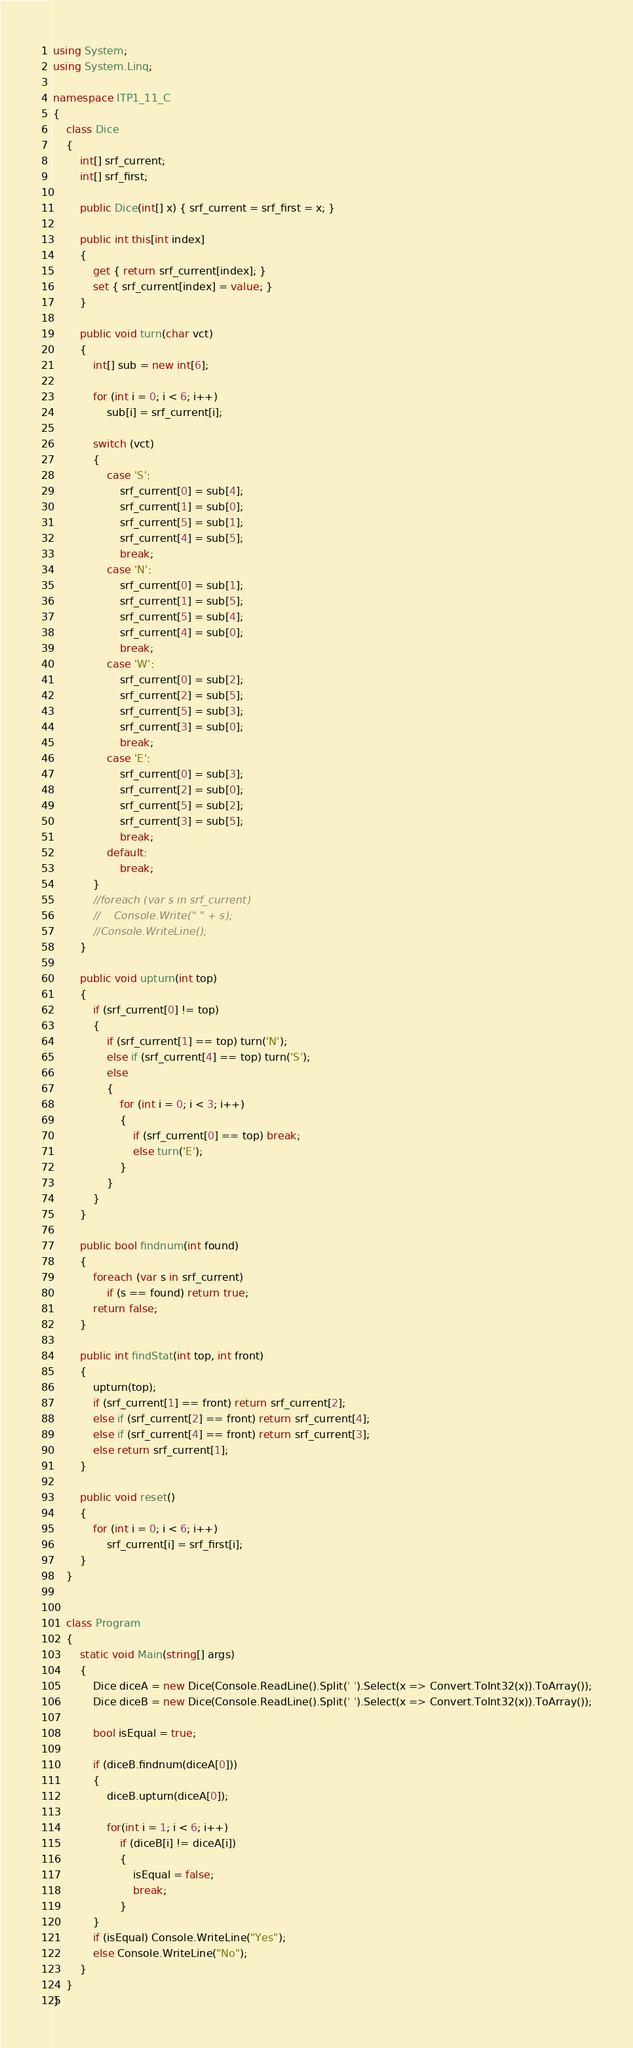Convert code to text. <code><loc_0><loc_0><loc_500><loc_500><_C#_>using System;
using System.Linq;

namespace ITP1_11_C
{
    class Dice
    {
        int[] srf_current;
        int[] srf_first;

        public Dice(int[] x) { srf_current = srf_first = x; }

        public int this[int index]
        {
            get { return srf_current[index]; }
            set { srf_current[index] = value; }
        }

        public void turn(char vct)
        {
            int[] sub = new int[6];

            for (int i = 0; i < 6; i++)
                sub[i] = srf_current[i];

            switch (vct)
            {
                case 'S':
                    srf_current[0] = sub[4];
                    srf_current[1] = sub[0];
                    srf_current[5] = sub[1];
                    srf_current[4] = sub[5];
                    break;
                case 'N':
                    srf_current[0] = sub[1];
                    srf_current[1] = sub[5];
                    srf_current[5] = sub[4];
                    srf_current[4] = sub[0];
                    break;
                case 'W':
                    srf_current[0] = sub[2];
                    srf_current[2] = sub[5];
                    srf_current[5] = sub[3];
                    srf_current[3] = sub[0];
                    break;
                case 'E':
                    srf_current[0] = sub[3];
                    srf_current[2] = sub[0];
                    srf_current[5] = sub[2];
                    srf_current[3] = sub[5];
                    break;
                default:
                    break;
            }
            //foreach (var s in srf_current)
            //    Console.Write(" " + s);
            //Console.WriteLine();
        }

        public void upturn(int top)
        {
            if (srf_current[0] != top)
            {
                if (srf_current[1] == top) turn('N');
                else if (srf_current[4] == top) turn('S');
                else
                {
                    for (int i = 0; i < 3; i++)
                    {
                        if (srf_current[0] == top) break;
                        else turn('E');
                    }
                }
            }
        }

        public bool findnum(int found)
        {
            foreach (var s in srf_current)
                if (s == found) return true;
            return false;
        }

        public int findStat(int top, int front)
        {
            upturn(top);
            if (srf_current[1] == front) return srf_current[2];
            else if (srf_current[2] == front) return srf_current[4];
            else if (srf_current[4] == front) return srf_current[3];
            else return srf_current[1];
        }

        public void reset()
        {
            for (int i = 0; i < 6; i++)
                srf_current[i] = srf_first[i];
        }
    }


    class Program
    {
        static void Main(string[] args)
        {
            Dice diceA = new Dice(Console.ReadLine().Split(' ').Select(x => Convert.ToInt32(x)).ToArray());
            Dice diceB = new Dice(Console.ReadLine().Split(' ').Select(x => Convert.ToInt32(x)).ToArray());

            bool isEqual = true;

            if (diceB.findnum(diceA[0]))
            {
                diceB.upturn(diceA[0]);

                for(int i = 1; i < 6; i++)
                    if (diceB[i] != diceA[i])
                    {
                        isEqual = false;
                        break;
                    }
            }
            if (isEqual) Console.WriteLine("Yes");
            else Console.WriteLine("No");
        }
    }
}</code> 